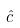<formula> <loc_0><loc_0><loc_500><loc_500>\hat { c }</formula> 